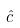<formula> <loc_0><loc_0><loc_500><loc_500>\hat { c }</formula> 